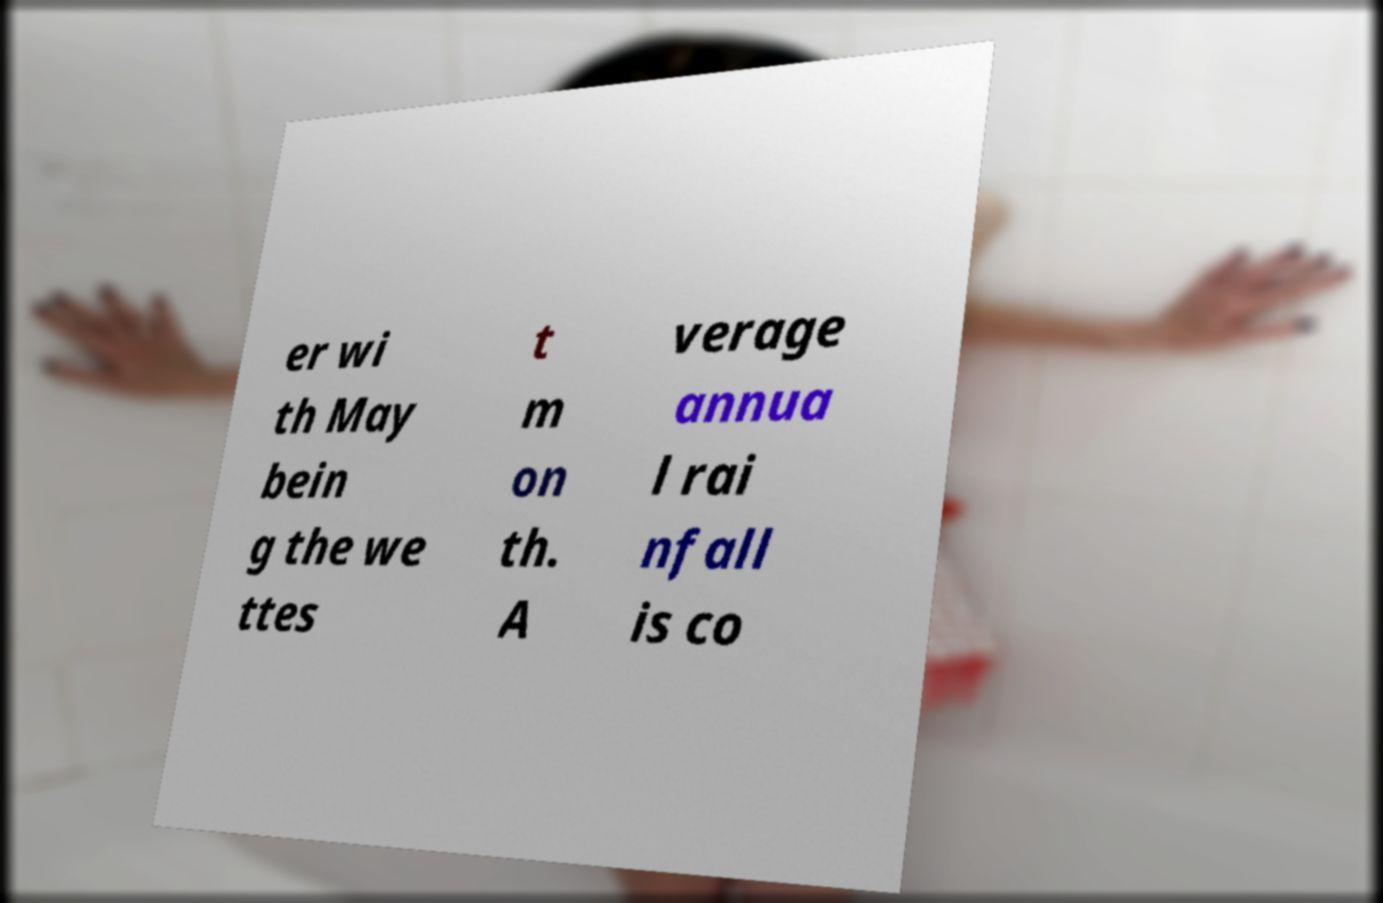Could you assist in decoding the text presented in this image and type it out clearly? er wi th May bein g the we ttes t m on th. A verage annua l rai nfall is co 